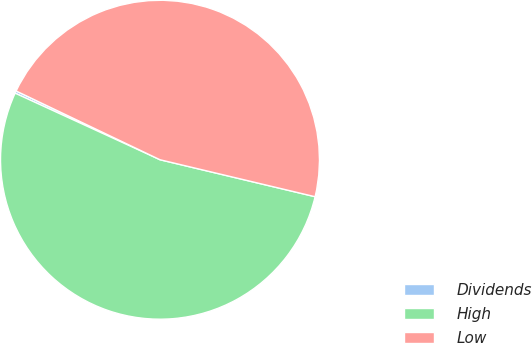<chart> <loc_0><loc_0><loc_500><loc_500><pie_chart><fcel>Dividends<fcel>High<fcel>Low<nl><fcel>0.24%<fcel>53.13%<fcel>46.63%<nl></chart> 